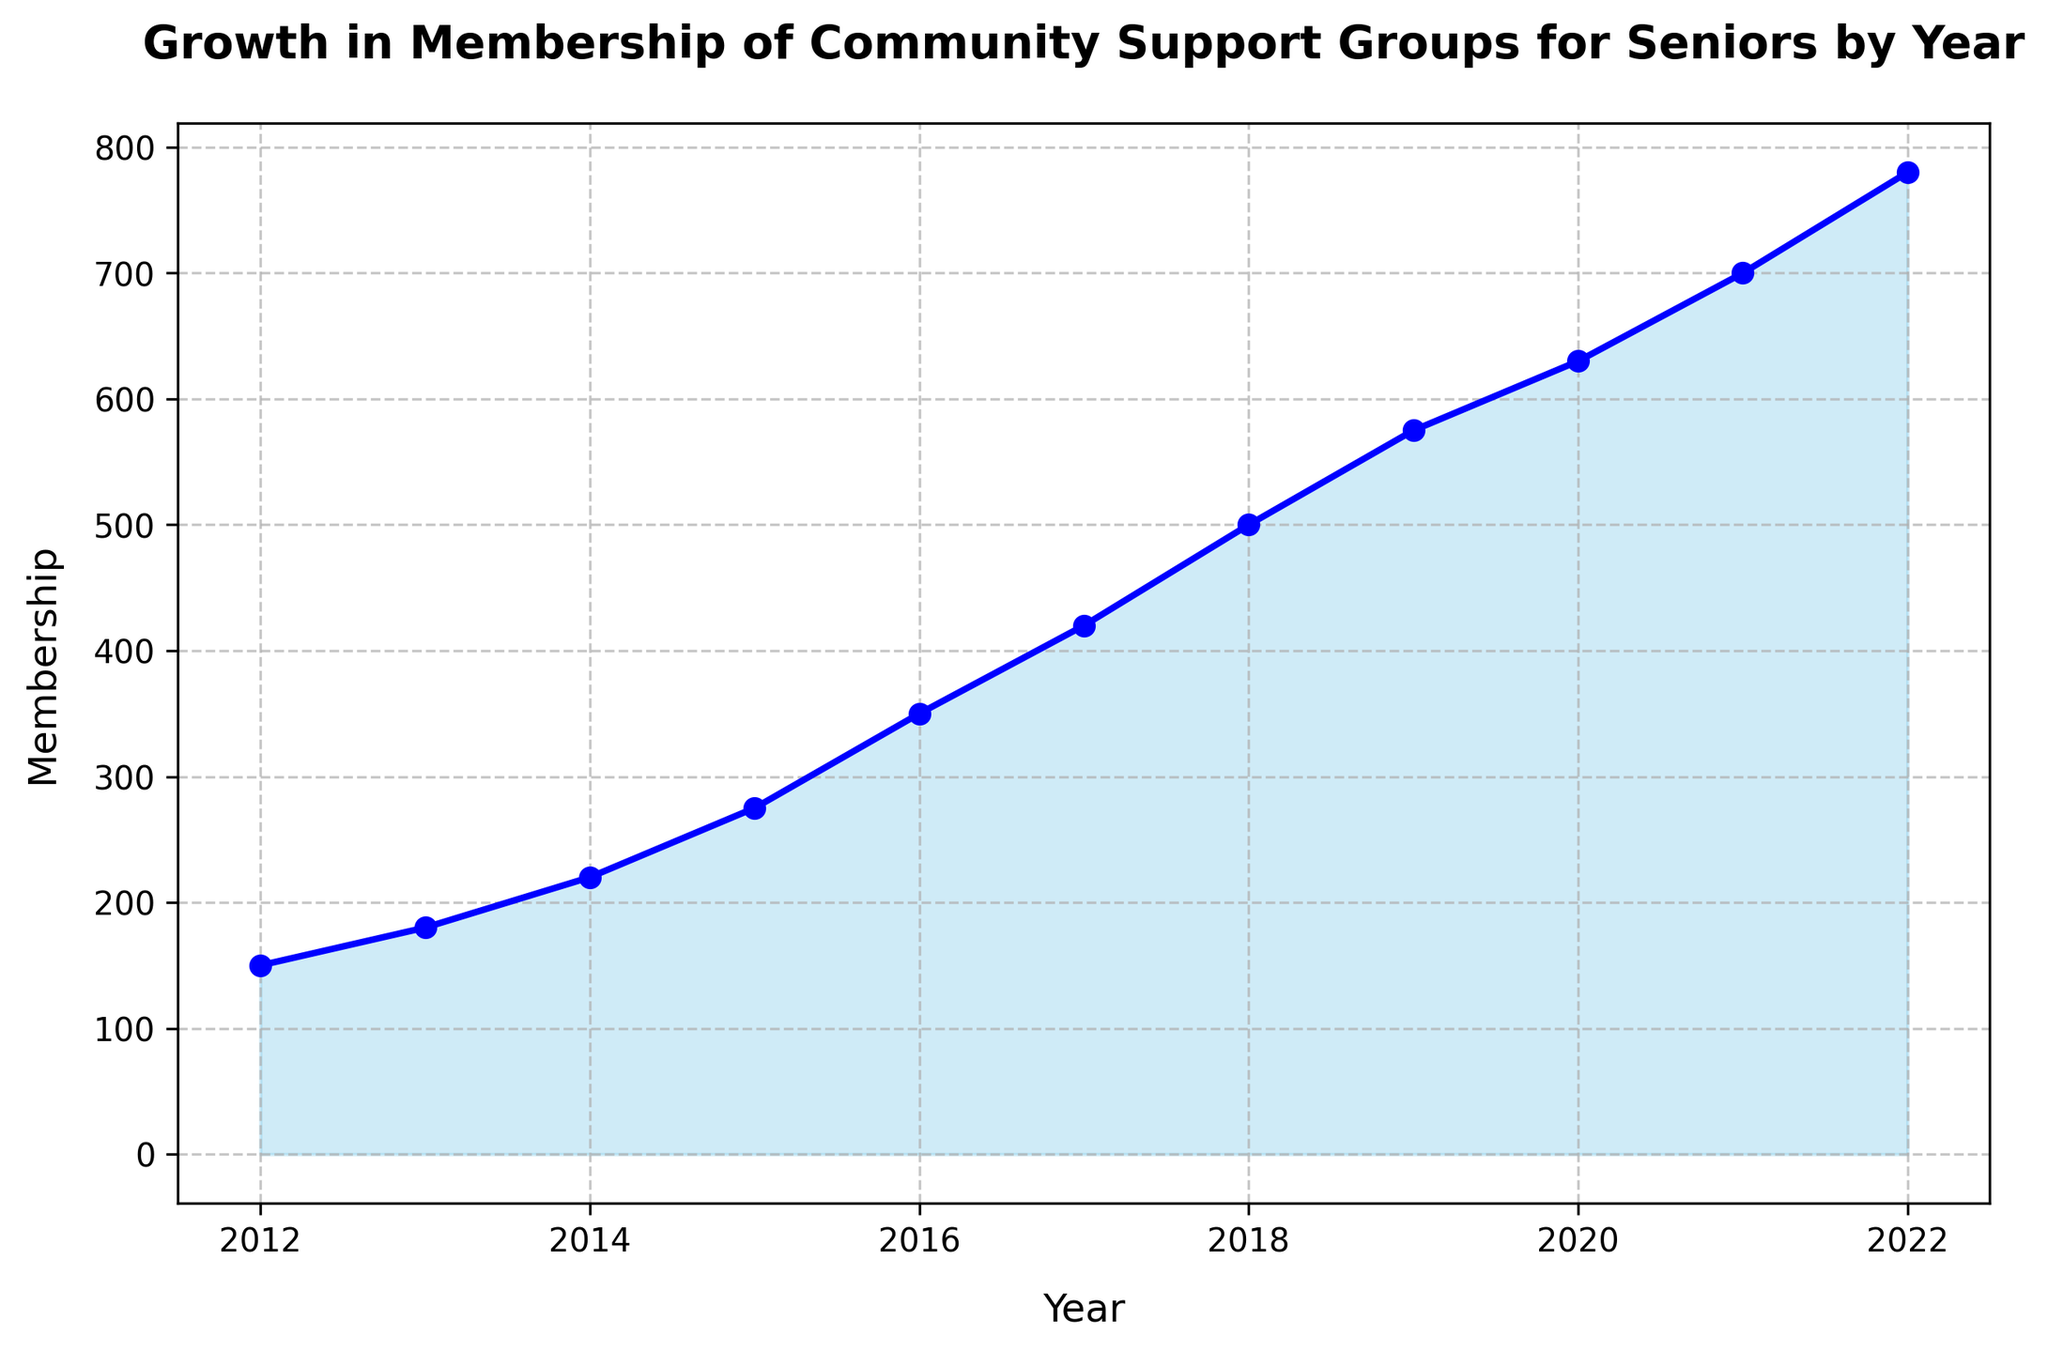What year had the highest membership? The highest point on the chart corresponds to the year 2022, with the greatest membership value.
Answer: 2022 In what year did the membership first exceed 500? The chart shows that the membership first went over 500 in 2018.
Answer: 2018 How much did the membership increase between 2015 and 2019? The membership in 2015 was 275 and in 2019 it was 575. The increase is 575 - 275.
Answer: 300 What is the average annual membership over the period? The sum of memberships from 2012 to 2022 is 150 + 180 + 220 + 275 + 350 + 420 + 500 + 575 + 630 + 700 + 780 = 4780. There are 11 years, so the average is 4780 / 11.
Answer: 435 Between which consecutive years was the largest increase in membership observed? The largest step occurs between any two consecutive ticks where the increase is the most pronounced. The largest increase is from 2014 (220) to 2015 (275), which is 55. However, a larger increase is observed from 2016 (350) to 2017 (420), which is 70.
Answer: 2016 to 2017 Which year's membership is just slightly greater than 600? On the chart, the value slightly greater than 600 is observed at 2020, with membership around 630.
Answer: 2020 How consistent has the membership growth been over these years? Has there been any decline? Visual inspection of the chart shows a generally steady and increasing trend in membership, with no instances of decline.
Answer: Always increasing By approximately how much has membership increased each year on average? The total increase from 2012 (150) to 2022 (780) is 780 - 150 = 630 over 10 years. Thus, the average annual increase is 630 / 10.
Answer: 63 How does the increase in membership from 2019 to 2020 compare to other years? The increase from 2019 (575) to 2020 (630) is 55, which is consistent but not the largest when compared with other years like 2016 to 2017's increase of 70.
Answer: Moderate increase 